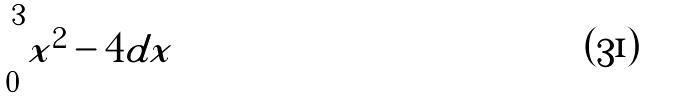<formula> <loc_0><loc_0><loc_500><loc_500>\int _ { 0 } ^ { 3 } | x ^ { 2 } - 4 | d x</formula> 